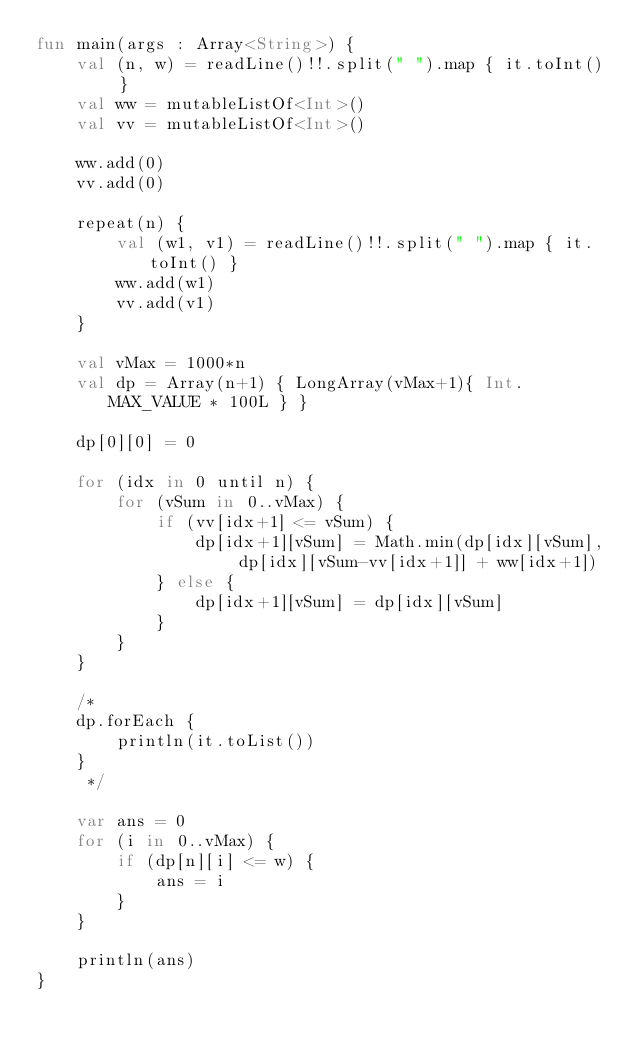<code> <loc_0><loc_0><loc_500><loc_500><_Kotlin_>fun main(args : Array<String>) {
    val (n, w) = readLine()!!.split(" ").map { it.toInt() }
    val ww = mutableListOf<Int>()
    val vv = mutableListOf<Int>()

    ww.add(0)
    vv.add(0)

    repeat(n) {
        val (w1, v1) = readLine()!!.split(" ").map { it.toInt() }
        ww.add(w1)
        vv.add(v1)
    }

    val vMax = 1000*n
    val dp = Array(n+1) { LongArray(vMax+1){ Int.MAX_VALUE * 100L } }

    dp[0][0] = 0

    for (idx in 0 until n) {
        for (vSum in 0..vMax) {
            if (vv[idx+1] <= vSum) {
                dp[idx+1][vSum] = Math.min(dp[idx][vSum], dp[idx][vSum-vv[idx+1]] + ww[idx+1])
            } else {
                dp[idx+1][vSum] = dp[idx][vSum]
            }
        }
    }

    /*
    dp.forEach {
        println(it.toList())
    }
     */

    var ans = 0
    for (i in 0..vMax) {
        if (dp[n][i] <= w) {
            ans = i
        }
    }

    println(ans)
}</code> 